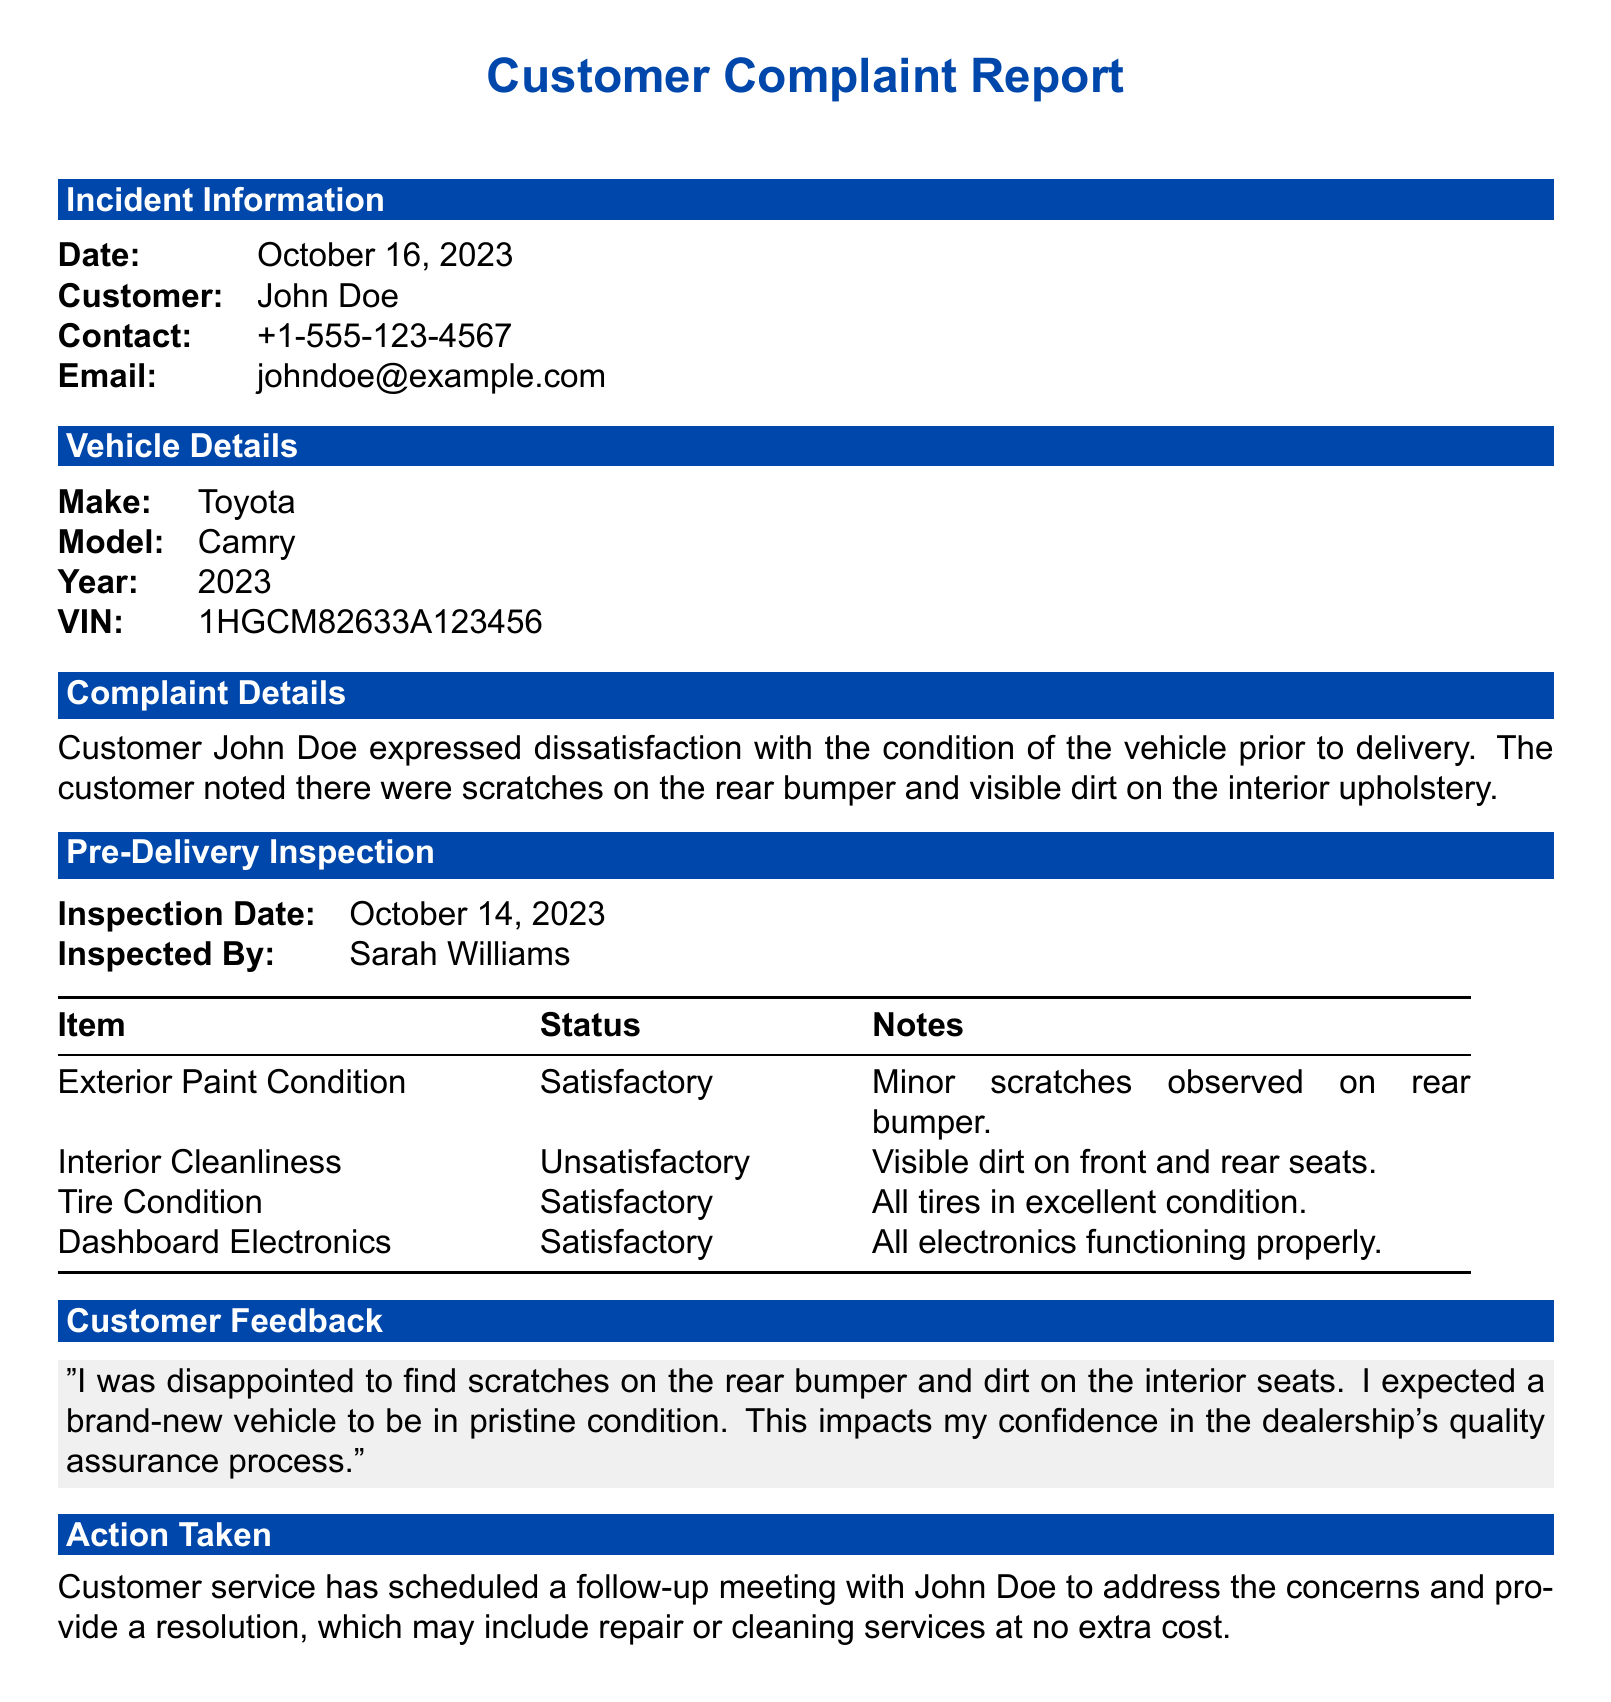What is the date of the customer complaint? The date of the complaint is explicitly stated in the incident information section of the document.
Answer: October 16, 2023 Who inspected the vehicle? The document specifies the name of the person who conducted the pre-delivery inspection.
Answer: Sarah Williams What was the condition of the tire? The tire condition is noted in the pre-delivery inspection checklist.
Answer: Satisfactory What specific issues did the customer report? The document includes details on the customer's complaints regarding the vehicle's condition.
Answer: Scratches on the rear bumper and visible dirt on the interior upholstery What action has been taken by customer service? The document describes the response to the customer's complaint, including follow-up procedures.
Answer: Scheduled a follow-up meeting What was the inspection date? The inspection date is recorded in the pre-delivery inspection section of the report.
Answer: October 14, 2023 How did the customer feel about the vehicle condition? The feedback section contains the customer's sentiments about the vehicle's state before delivery.
Answer: Disappointed What was the status of the interior cleanliness? The document lists the status for various inspection items, including interior cleanliness.
Answer: Unsatisfactory 